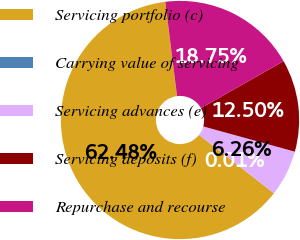Convert chart. <chart><loc_0><loc_0><loc_500><loc_500><pie_chart><fcel>Servicing portfolio (c)<fcel>Carrying value of servicing<fcel>Servicing advances (e)<fcel>Servicing deposits (f)<fcel>Repurchase and recourse<nl><fcel>62.48%<fcel>0.01%<fcel>6.26%<fcel>12.5%<fcel>18.75%<nl></chart> 